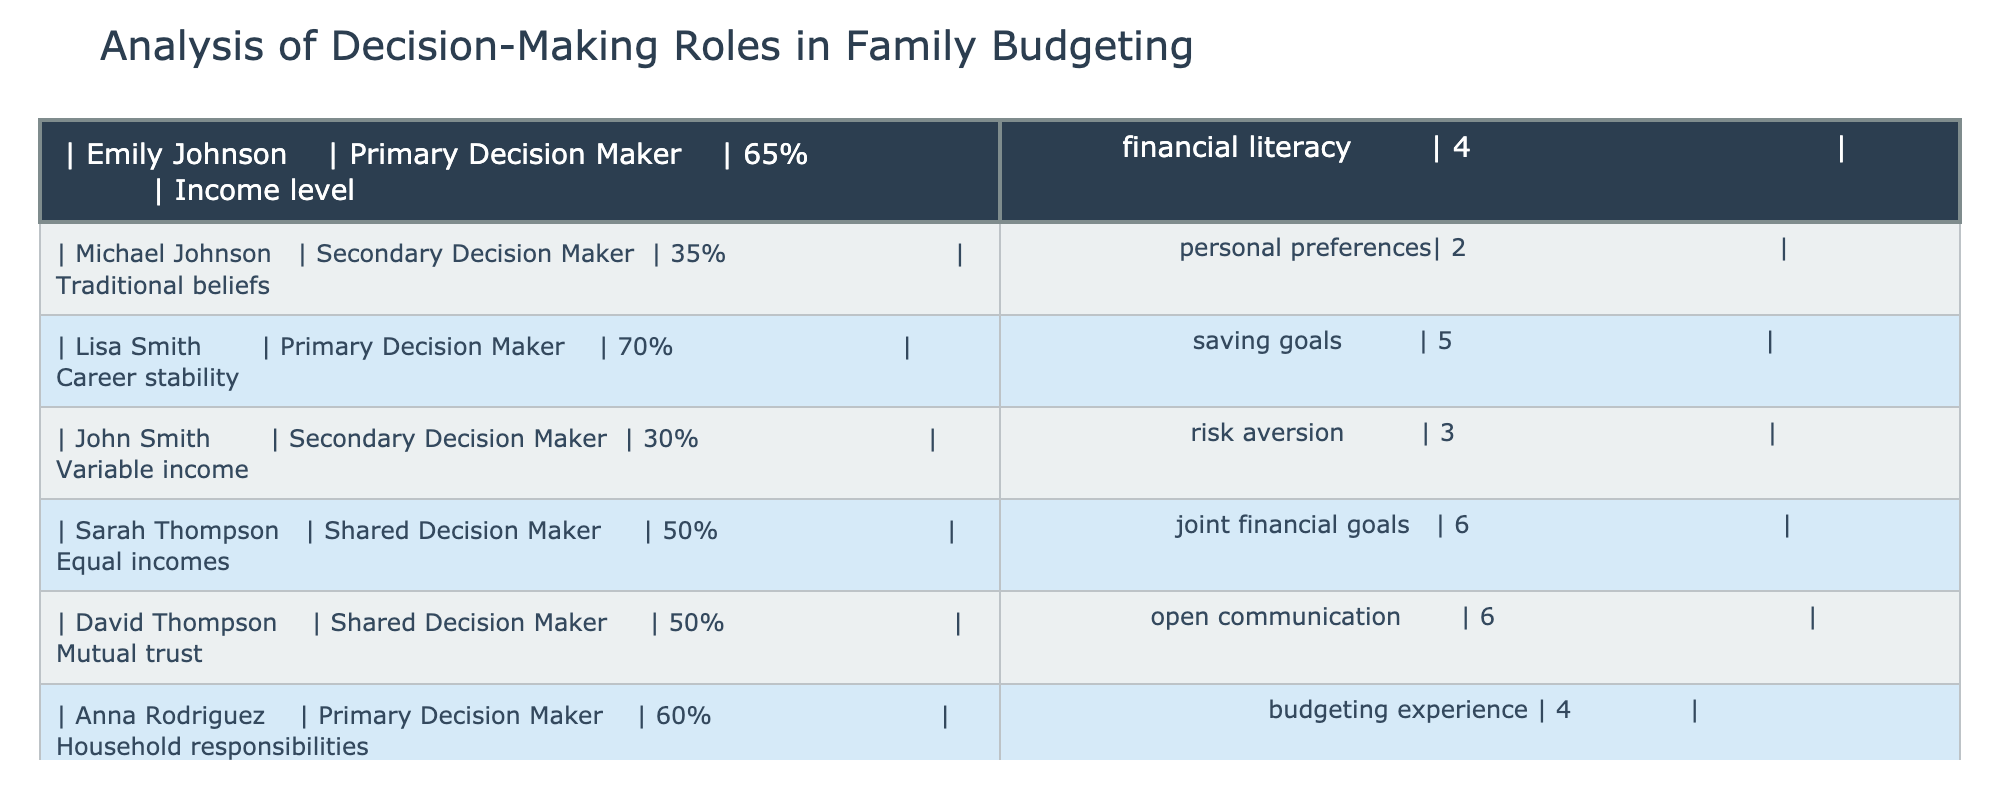What percentage of decision makers are secondary decision makers? From the table, the secondary decision makers are Michael Johnson (35%), John Smith (30%), and Carlos Rodriguez (40%). To find the total percentage: 35 + 30 + 40 = 105. There are 8 individuals, thus the percentage of secondary decision makers is 105/8 = 13.125%.
Answer: 13.125% Which individual has the highest financial literacy score and what is it? By inspecting the table, it is noted that Lisa Smith has the highest financial literacy score of 5. This can be seen directly in the financial literacy column of the data.
Answer: 5 Is there anyone with shared decision-making roles in the family budgeting? Yes, there are two individuals with shared decision-making roles: Sarah Thompson and David Thompson. This is evident in the role column where both have been categorized as shared decision makers.
Answer: Yes What is the average income level of primary decision makers? The income levels for primary decision makers are: 65% (Emily Johnson), 70% (Lisa Smith), and 60% (Anna Rodriguez). To find the average, sum these percentages: 65 + 70 + 60 = 195 and divide by the number of primary decision makers (3). Thus, 195 / 3 = 65%.
Answer: 65% Do secondary decision makers have lower financial literacy scores compared to primary decision makers? Yes, the financial literacy scores of secondary decision makers are: 2 (Michael Johnson), 3 (John Smith), and 2 (Carlos Rodriguez), averaging to (2 + 3 + 2)/3 = 2.33. The primary decision makers average is (4 + 5 + 4)/3 = 4.33. Since 2.33 < 4.33, this confirms that secondary decision makers have lower financial literacy scores.
Answer: Yes 